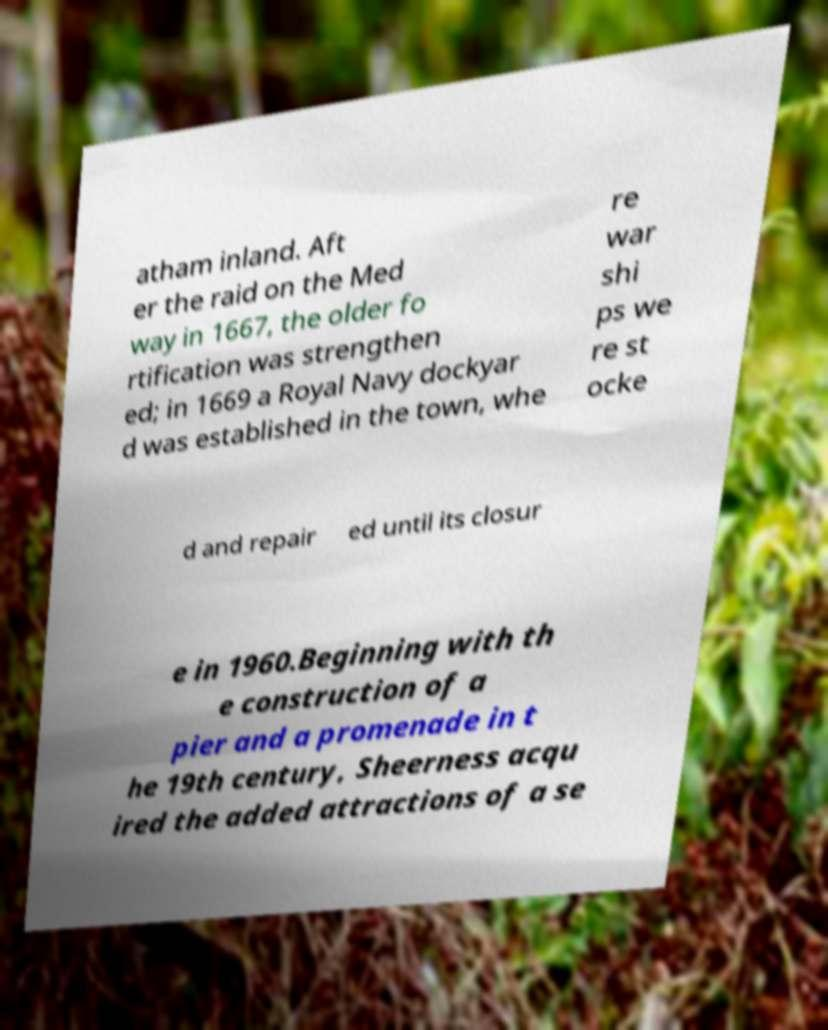Can you accurately transcribe the text from the provided image for me? atham inland. Aft er the raid on the Med way in 1667, the older fo rtification was strengthen ed; in 1669 a Royal Navy dockyar d was established in the town, whe re war shi ps we re st ocke d and repair ed until its closur e in 1960.Beginning with th e construction of a pier and a promenade in t he 19th century, Sheerness acqu ired the added attractions of a se 